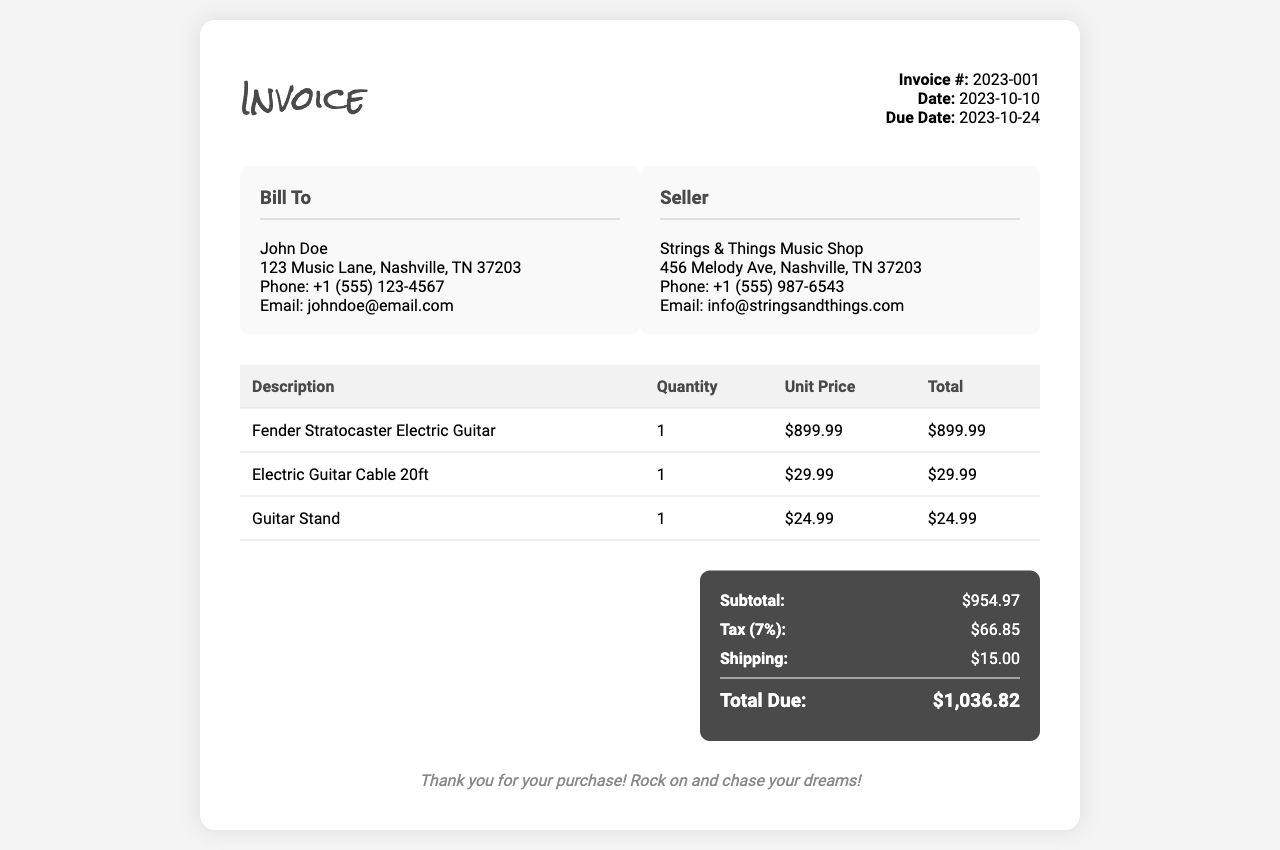What is the invoice number? The invoice number is displayed prominently near the top right of the document.
Answer: 2023-001 Who is the seller? The seller's name is listed in the "Seller" section of the invoice.
Answer: Strings & Things Music Shop What is the payment due date? The due date for payment is provided near the invoice number and date.
Answer: 2023-10-24 How much is the subtotal? The subtotal is shown in the total section of the invoice.
Answer: $954.97 What is the tax percentage applied? The tax percentage is indicated alongside the tax amount in the total section.
Answer: 7% What item has the highest price? The item with the highest price can be determined by looking at the unit prices in the table.
Answer: Fender Stratocaster Electric Guitar What is the total amount due? The total amount due is located at the end of the total section.
Answer: $1,036.82 What is the shipping cost? The shipping cost is specified in the total section of the invoice.
Answer: $15.00 How many guitar stands were purchased? The quantity of guitar stands is shown in the itemized list of purchases.
Answer: 1 